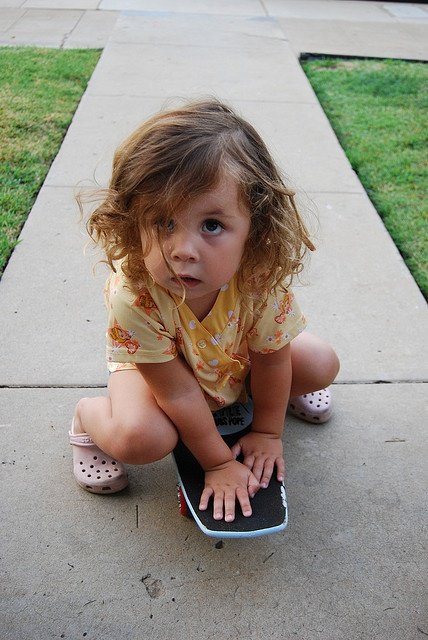Describe the objects in this image and their specific colors. I can see people in lightgray, gray, maroon, black, and brown tones and skateboard in lightgray, black, gray, maroon, and lightblue tones in this image. 